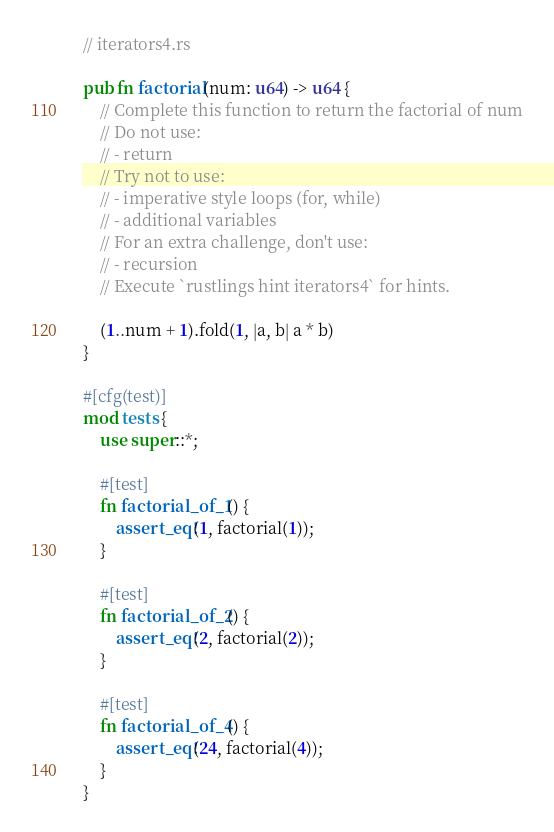<code> <loc_0><loc_0><loc_500><loc_500><_Rust_>// iterators4.rs

pub fn factorial(num: u64) -> u64 {
    // Complete this function to return the factorial of num
    // Do not use:
    // - return
    // Try not to use:
    // - imperative style loops (for, while)
    // - additional variables
    // For an extra challenge, don't use:
    // - recursion
    // Execute `rustlings hint iterators4` for hints.

    (1..num + 1).fold(1, |a, b| a * b)
}

#[cfg(test)]
mod tests {
    use super::*;

    #[test]
    fn factorial_of_1() {
        assert_eq!(1, factorial(1));
    }

    #[test]
    fn factorial_of_2() {
        assert_eq!(2, factorial(2));
    }

    #[test]
    fn factorial_of_4() {
        assert_eq!(24, factorial(4));
    }
}
</code> 